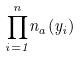Convert formula to latex. <formula><loc_0><loc_0><loc_500><loc_500>\overset { n } { \underset { i = 1 } { \prod } } n _ { a } ( y _ { i } )</formula> 